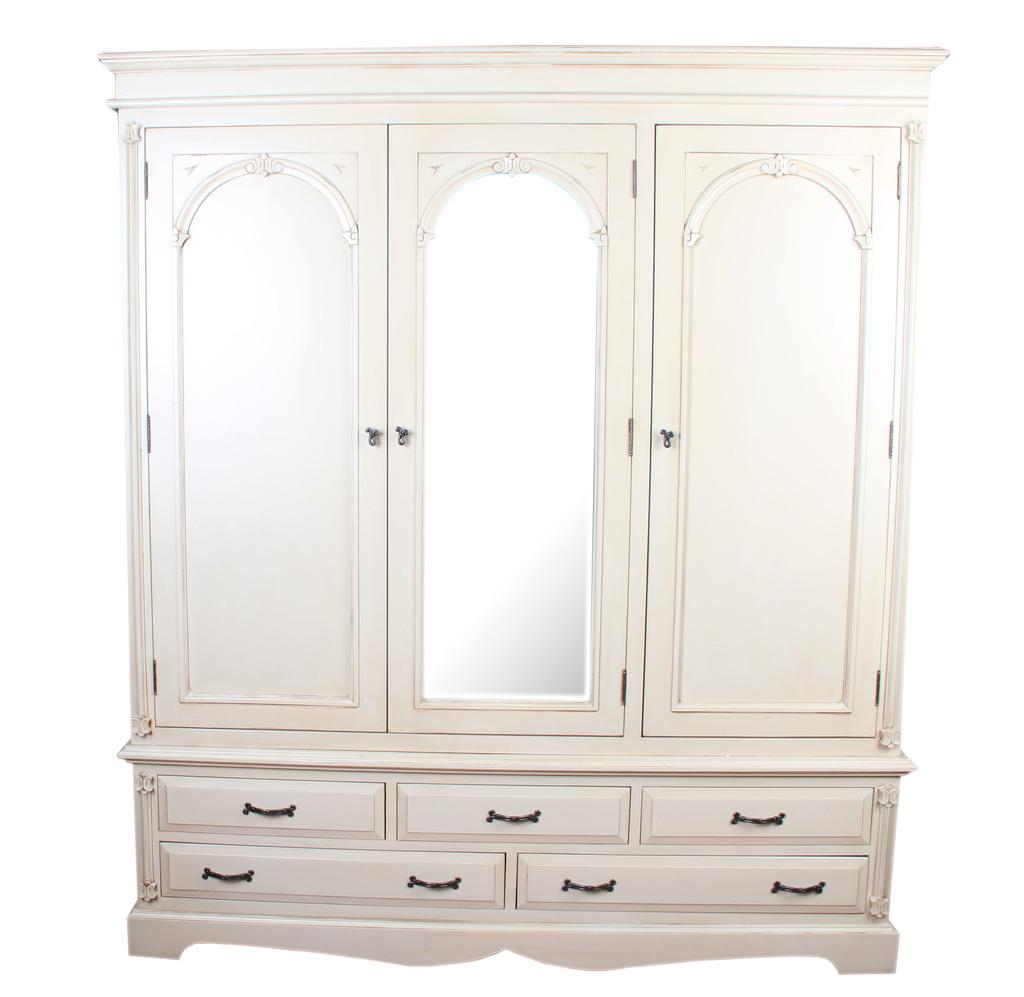What type of furniture is present in the image? There is a wardrobe in the image. What might the wardrobe be used for? The wardrobe is likely used for storing clothes or other items. Can you describe the wardrobe's appearance? The wardrobe's appearance cannot be determined from the provided facts. What type of jeans is hanging inside the wardrobe in the image? There is no information about jeans or any other clothing items present in the image. 